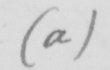Please provide the text content of this handwritten line. ( a ) 